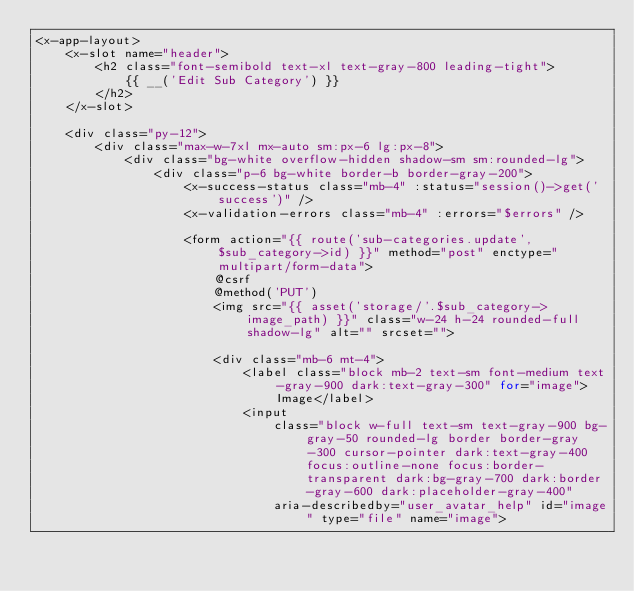<code> <loc_0><loc_0><loc_500><loc_500><_PHP_><x-app-layout>
    <x-slot name="header">
        <h2 class="font-semibold text-xl text-gray-800 leading-tight">
            {{ __('Edit Sub Category') }}
        </h2>
    </x-slot>

    <div class="py-12">
        <div class="max-w-7xl mx-auto sm:px-6 lg:px-8">
            <div class="bg-white overflow-hidden shadow-sm sm:rounded-lg">
                <div class="p-6 bg-white border-b border-gray-200">
                    <x-success-status class="mb-4" :status="session()->get('success')" />
                    <x-validation-errors class="mb-4" :errors="$errors" />

                    <form action="{{ route('sub-categories.update',$sub_category->id) }}" method="post" enctype="multipart/form-data">
                        @csrf
                        @method('PUT')
                        <img src="{{ asset('storage/'.$sub_category->image_path) }}" class="w-24 h-24 rounded-full shadow-lg" alt="" srcset="">

                        <div class="mb-6 mt-4">
                            <label class="block mb-2 text-sm font-medium text-gray-900 dark:text-gray-300" for="image">Image</label>
                            <input
                                class="block w-full text-sm text-gray-900 bg-gray-50 rounded-lg border border-gray-300 cursor-pointer dark:text-gray-400 focus:outline-none focus:border-transparent dark:bg-gray-700 dark:border-gray-600 dark:placeholder-gray-400"
                                aria-describedby="user_avatar_help" id="image" type="file" name="image"></code> 